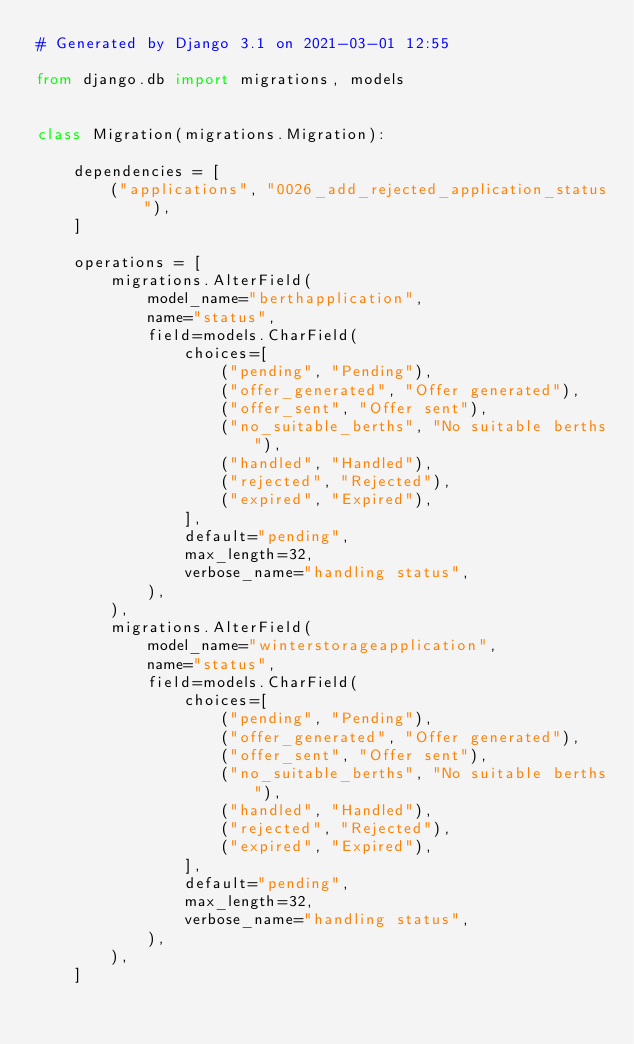<code> <loc_0><loc_0><loc_500><loc_500><_Python_># Generated by Django 3.1 on 2021-03-01 12:55

from django.db import migrations, models


class Migration(migrations.Migration):

    dependencies = [
        ("applications", "0026_add_rejected_application_status"),
    ]

    operations = [
        migrations.AlterField(
            model_name="berthapplication",
            name="status",
            field=models.CharField(
                choices=[
                    ("pending", "Pending"),
                    ("offer_generated", "Offer generated"),
                    ("offer_sent", "Offer sent"),
                    ("no_suitable_berths", "No suitable berths"),
                    ("handled", "Handled"),
                    ("rejected", "Rejected"),
                    ("expired", "Expired"),
                ],
                default="pending",
                max_length=32,
                verbose_name="handling status",
            ),
        ),
        migrations.AlterField(
            model_name="winterstorageapplication",
            name="status",
            field=models.CharField(
                choices=[
                    ("pending", "Pending"),
                    ("offer_generated", "Offer generated"),
                    ("offer_sent", "Offer sent"),
                    ("no_suitable_berths", "No suitable berths"),
                    ("handled", "Handled"),
                    ("rejected", "Rejected"),
                    ("expired", "Expired"),
                ],
                default="pending",
                max_length=32,
                verbose_name="handling status",
            ),
        ),
    ]
</code> 